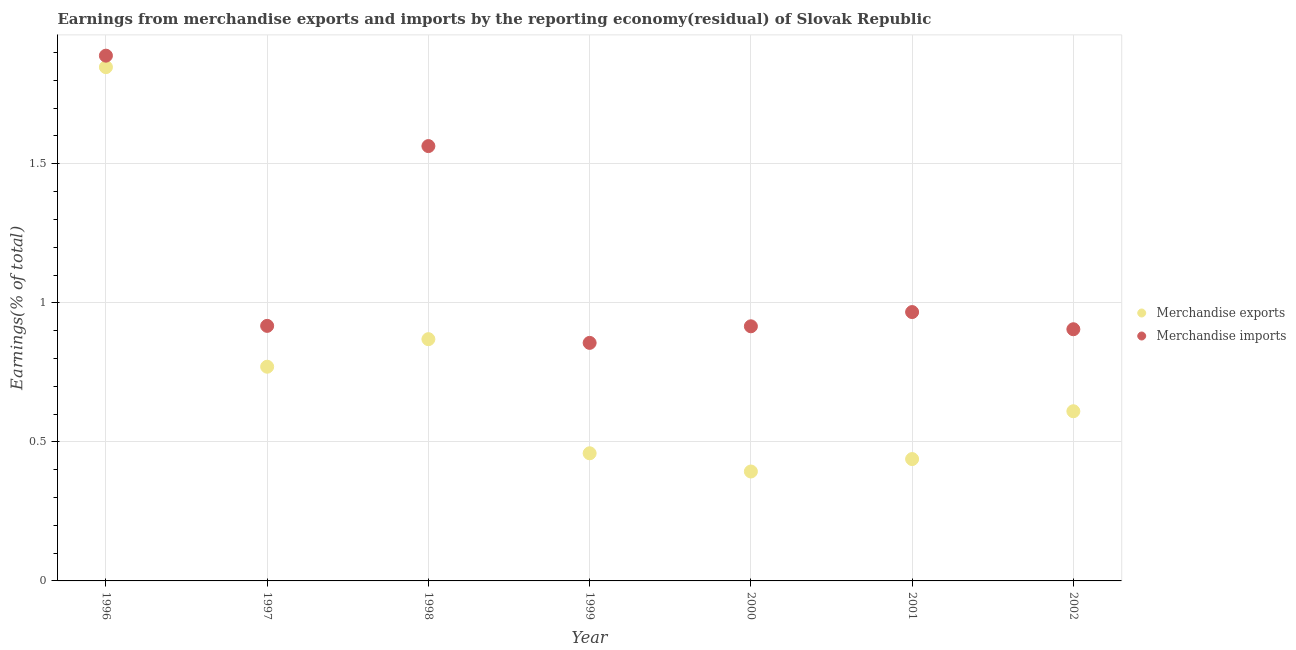How many different coloured dotlines are there?
Provide a succinct answer. 2. Is the number of dotlines equal to the number of legend labels?
Make the answer very short. Yes. What is the earnings from merchandise imports in 1996?
Ensure brevity in your answer.  1.89. Across all years, what is the maximum earnings from merchandise imports?
Ensure brevity in your answer.  1.89. Across all years, what is the minimum earnings from merchandise imports?
Ensure brevity in your answer.  0.86. In which year was the earnings from merchandise imports minimum?
Provide a succinct answer. 1999. What is the total earnings from merchandise exports in the graph?
Your answer should be very brief. 5.39. What is the difference between the earnings from merchandise imports in 1997 and that in 1999?
Give a very brief answer. 0.06. What is the difference between the earnings from merchandise imports in 1997 and the earnings from merchandise exports in 1998?
Provide a short and direct response. 0.05. What is the average earnings from merchandise imports per year?
Provide a succinct answer. 1.14. In the year 2001, what is the difference between the earnings from merchandise exports and earnings from merchandise imports?
Offer a very short reply. -0.53. What is the ratio of the earnings from merchandise exports in 1996 to that in 2001?
Keep it short and to the point. 4.22. Is the earnings from merchandise imports in 1998 less than that in 1999?
Your answer should be very brief. No. What is the difference between the highest and the second highest earnings from merchandise imports?
Your answer should be compact. 0.33. What is the difference between the highest and the lowest earnings from merchandise imports?
Make the answer very short. 1.03. In how many years, is the earnings from merchandise imports greater than the average earnings from merchandise imports taken over all years?
Provide a short and direct response. 2. Does the earnings from merchandise imports monotonically increase over the years?
Offer a very short reply. No. Is the earnings from merchandise imports strictly greater than the earnings from merchandise exports over the years?
Offer a very short reply. Yes. Is the earnings from merchandise imports strictly less than the earnings from merchandise exports over the years?
Provide a short and direct response. No. How many dotlines are there?
Your response must be concise. 2. How many years are there in the graph?
Make the answer very short. 7. Are the values on the major ticks of Y-axis written in scientific E-notation?
Keep it short and to the point. No. Does the graph contain any zero values?
Provide a short and direct response. No. How many legend labels are there?
Keep it short and to the point. 2. What is the title of the graph?
Keep it short and to the point. Earnings from merchandise exports and imports by the reporting economy(residual) of Slovak Republic. What is the label or title of the X-axis?
Your response must be concise. Year. What is the label or title of the Y-axis?
Your answer should be very brief. Earnings(% of total). What is the Earnings(% of total) in Merchandise exports in 1996?
Your answer should be compact. 1.85. What is the Earnings(% of total) of Merchandise imports in 1996?
Your answer should be compact. 1.89. What is the Earnings(% of total) of Merchandise exports in 1997?
Your answer should be compact. 0.77. What is the Earnings(% of total) in Merchandise imports in 1997?
Ensure brevity in your answer.  0.92. What is the Earnings(% of total) of Merchandise exports in 1998?
Make the answer very short. 0.87. What is the Earnings(% of total) in Merchandise imports in 1998?
Your answer should be very brief. 1.56. What is the Earnings(% of total) in Merchandise exports in 1999?
Your response must be concise. 0.46. What is the Earnings(% of total) in Merchandise imports in 1999?
Provide a short and direct response. 0.86. What is the Earnings(% of total) in Merchandise exports in 2000?
Your answer should be very brief. 0.39. What is the Earnings(% of total) of Merchandise imports in 2000?
Offer a terse response. 0.92. What is the Earnings(% of total) in Merchandise exports in 2001?
Offer a terse response. 0.44. What is the Earnings(% of total) of Merchandise imports in 2001?
Offer a terse response. 0.97. What is the Earnings(% of total) of Merchandise exports in 2002?
Ensure brevity in your answer.  0.61. What is the Earnings(% of total) in Merchandise imports in 2002?
Offer a very short reply. 0.9. Across all years, what is the maximum Earnings(% of total) of Merchandise exports?
Offer a very short reply. 1.85. Across all years, what is the maximum Earnings(% of total) of Merchandise imports?
Make the answer very short. 1.89. Across all years, what is the minimum Earnings(% of total) in Merchandise exports?
Ensure brevity in your answer.  0.39. Across all years, what is the minimum Earnings(% of total) in Merchandise imports?
Give a very brief answer. 0.86. What is the total Earnings(% of total) in Merchandise exports in the graph?
Make the answer very short. 5.39. What is the total Earnings(% of total) of Merchandise imports in the graph?
Give a very brief answer. 8.01. What is the difference between the Earnings(% of total) in Merchandise exports in 1996 and that in 1997?
Your answer should be compact. 1.08. What is the difference between the Earnings(% of total) of Merchandise imports in 1996 and that in 1997?
Your answer should be very brief. 0.97. What is the difference between the Earnings(% of total) in Merchandise exports in 1996 and that in 1998?
Your answer should be compact. 0.98. What is the difference between the Earnings(% of total) in Merchandise imports in 1996 and that in 1998?
Offer a terse response. 0.33. What is the difference between the Earnings(% of total) of Merchandise exports in 1996 and that in 1999?
Ensure brevity in your answer.  1.39. What is the difference between the Earnings(% of total) of Merchandise imports in 1996 and that in 1999?
Your answer should be very brief. 1.03. What is the difference between the Earnings(% of total) of Merchandise exports in 1996 and that in 2000?
Provide a short and direct response. 1.45. What is the difference between the Earnings(% of total) in Merchandise imports in 1996 and that in 2000?
Provide a succinct answer. 0.97. What is the difference between the Earnings(% of total) in Merchandise exports in 1996 and that in 2001?
Make the answer very short. 1.41. What is the difference between the Earnings(% of total) in Merchandise imports in 1996 and that in 2001?
Keep it short and to the point. 0.92. What is the difference between the Earnings(% of total) in Merchandise exports in 1996 and that in 2002?
Provide a succinct answer. 1.24. What is the difference between the Earnings(% of total) in Merchandise imports in 1996 and that in 2002?
Give a very brief answer. 0.98. What is the difference between the Earnings(% of total) of Merchandise exports in 1997 and that in 1998?
Your answer should be compact. -0.1. What is the difference between the Earnings(% of total) in Merchandise imports in 1997 and that in 1998?
Offer a terse response. -0.65. What is the difference between the Earnings(% of total) in Merchandise exports in 1997 and that in 1999?
Ensure brevity in your answer.  0.31. What is the difference between the Earnings(% of total) of Merchandise imports in 1997 and that in 1999?
Your answer should be compact. 0.06. What is the difference between the Earnings(% of total) in Merchandise exports in 1997 and that in 2000?
Give a very brief answer. 0.38. What is the difference between the Earnings(% of total) of Merchandise imports in 1997 and that in 2000?
Offer a terse response. 0. What is the difference between the Earnings(% of total) in Merchandise exports in 1997 and that in 2001?
Provide a succinct answer. 0.33. What is the difference between the Earnings(% of total) in Merchandise imports in 1997 and that in 2001?
Offer a very short reply. -0.05. What is the difference between the Earnings(% of total) in Merchandise exports in 1997 and that in 2002?
Offer a very short reply. 0.16. What is the difference between the Earnings(% of total) in Merchandise imports in 1997 and that in 2002?
Make the answer very short. 0.01. What is the difference between the Earnings(% of total) of Merchandise exports in 1998 and that in 1999?
Ensure brevity in your answer.  0.41. What is the difference between the Earnings(% of total) of Merchandise imports in 1998 and that in 1999?
Your response must be concise. 0.71. What is the difference between the Earnings(% of total) in Merchandise exports in 1998 and that in 2000?
Your response must be concise. 0.48. What is the difference between the Earnings(% of total) in Merchandise imports in 1998 and that in 2000?
Your response must be concise. 0.65. What is the difference between the Earnings(% of total) of Merchandise exports in 1998 and that in 2001?
Provide a short and direct response. 0.43. What is the difference between the Earnings(% of total) in Merchandise imports in 1998 and that in 2001?
Offer a terse response. 0.6. What is the difference between the Earnings(% of total) in Merchandise exports in 1998 and that in 2002?
Make the answer very short. 0.26. What is the difference between the Earnings(% of total) of Merchandise imports in 1998 and that in 2002?
Your response must be concise. 0.66. What is the difference between the Earnings(% of total) of Merchandise exports in 1999 and that in 2000?
Your response must be concise. 0.07. What is the difference between the Earnings(% of total) in Merchandise imports in 1999 and that in 2000?
Keep it short and to the point. -0.06. What is the difference between the Earnings(% of total) in Merchandise exports in 1999 and that in 2001?
Provide a succinct answer. 0.02. What is the difference between the Earnings(% of total) in Merchandise imports in 1999 and that in 2001?
Ensure brevity in your answer.  -0.11. What is the difference between the Earnings(% of total) in Merchandise exports in 1999 and that in 2002?
Offer a very short reply. -0.15. What is the difference between the Earnings(% of total) of Merchandise imports in 1999 and that in 2002?
Offer a very short reply. -0.05. What is the difference between the Earnings(% of total) in Merchandise exports in 2000 and that in 2001?
Ensure brevity in your answer.  -0.04. What is the difference between the Earnings(% of total) in Merchandise imports in 2000 and that in 2001?
Give a very brief answer. -0.05. What is the difference between the Earnings(% of total) of Merchandise exports in 2000 and that in 2002?
Provide a succinct answer. -0.22. What is the difference between the Earnings(% of total) of Merchandise imports in 2000 and that in 2002?
Your answer should be very brief. 0.01. What is the difference between the Earnings(% of total) in Merchandise exports in 2001 and that in 2002?
Offer a very short reply. -0.17. What is the difference between the Earnings(% of total) of Merchandise imports in 2001 and that in 2002?
Offer a terse response. 0.06. What is the difference between the Earnings(% of total) of Merchandise exports in 1996 and the Earnings(% of total) of Merchandise imports in 1997?
Give a very brief answer. 0.93. What is the difference between the Earnings(% of total) in Merchandise exports in 1996 and the Earnings(% of total) in Merchandise imports in 1998?
Your answer should be compact. 0.28. What is the difference between the Earnings(% of total) of Merchandise exports in 1996 and the Earnings(% of total) of Merchandise imports in 1999?
Your response must be concise. 0.99. What is the difference between the Earnings(% of total) of Merchandise exports in 1996 and the Earnings(% of total) of Merchandise imports in 2000?
Offer a very short reply. 0.93. What is the difference between the Earnings(% of total) in Merchandise exports in 1996 and the Earnings(% of total) in Merchandise imports in 2001?
Give a very brief answer. 0.88. What is the difference between the Earnings(% of total) of Merchandise exports in 1996 and the Earnings(% of total) of Merchandise imports in 2002?
Keep it short and to the point. 0.94. What is the difference between the Earnings(% of total) in Merchandise exports in 1997 and the Earnings(% of total) in Merchandise imports in 1998?
Your response must be concise. -0.79. What is the difference between the Earnings(% of total) in Merchandise exports in 1997 and the Earnings(% of total) in Merchandise imports in 1999?
Your answer should be compact. -0.09. What is the difference between the Earnings(% of total) of Merchandise exports in 1997 and the Earnings(% of total) of Merchandise imports in 2000?
Provide a short and direct response. -0.15. What is the difference between the Earnings(% of total) in Merchandise exports in 1997 and the Earnings(% of total) in Merchandise imports in 2001?
Provide a short and direct response. -0.2. What is the difference between the Earnings(% of total) of Merchandise exports in 1997 and the Earnings(% of total) of Merchandise imports in 2002?
Make the answer very short. -0.13. What is the difference between the Earnings(% of total) of Merchandise exports in 1998 and the Earnings(% of total) of Merchandise imports in 1999?
Give a very brief answer. 0.01. What is the difference between the Earnings(% of total) of Merchandise exports in 1998 and the Earnings(% of total) of Merchandise imports in 2000?
Ensure brevity in your answer.  -0.05. What is the difference between the Earnings(% of total) of Merchandise exports in 1998 and the Earnings(% of total) of Merchandise imports in 2001?
Give a very brief answer. -0.1. What is the difference between the Earnings(% of total) in Merchandise exports in 1998 and the Earnings(% of total) in Merchandise imports in 2002?
Offer a very short reply. -0.04. What is the difference between the Earnings(% of total) in Merchandise exports in 1999 and the Earnings(% of total) in Merchandise imports in 2000?
Provide a succinct answer. -0.46. What is the difference between the Earnings(% of total) of Merchandise exports in 1999 and the Earnings(% of total) of Merchandise imports in 2001?
Keep it short and to the point. -0.51. What is the difference between the Earnings(% of total) of Merchandise exports in 1999 and the Earnings(% of total) of Merchandise imports in 2002?
Make the answer very short. -0.45. What is the difference between the Earnings(% of total) in Merchandise exports in 2000 and the Earnings(% of total) in Merchandise imports in 2001?
Your answer should be compact. -0.57. What is the difference between the Earnings(% of total) in Merchandise exports in 2000 and the Earnings(% of total) in Merchandise imports in 2002?
Your answer should be very brief. -0.51. What is the difference between the Earnings(% of total) of Merchandise exports in 2001 and the Earnings(% of total) of Merchandise imports in 2002?
Offer a terse response. -0.47. What is the average Earnings(% of total) in Merchandise exports per year?
Your response must be concise. 0.77. What is the average Earnings(% of total) in Merchandise imports per year?
Make the answer very short. 1.14. In the year 1996, what is the difference between the Earnings(% of total) in Merchandise exports and Earnings(% of total) in Merchandise imports?
Keep it short and to the point. -0.04. In the year 1997, what is the difference between the Earnings(% of total) in Merchandise exports and Earnings(% of total) in Merchandise imports?
Your answer should be compact. -0.15. In the year 1998, what is the difference between the Earnings(% of total) in Merchandise exports and Earnings(% of total) in Merchandise imports?
Your answer should be very brief. -0.69. In the year 1999, what is the difference between the Earnings(% of total) of Merchandise exports and Earnings(% of total) of Merchandise imports?
Your answer should be compact. -0.4. In the year 2000, what is the difference between the Earnings(% of total) in Merchandise exports and Earnings(% of total) in Merchandise imports?
Provide a short and direct response. -0.52. In the year 2001, what is the difference between the Earnings(% of total) of Merchandise exports and Earnings(% of total) of Merchandise imports?
Keep it short and to the point. -0.53. In the year 2002, what is the difference between the Earnings(% of total) of Merchandise exports and Earnings(% of total) of Merchandise imports?
Offer a very short reply. -0.29. What is the ratio of the Earnings(% of total) of Merchandise exports in 1996 to that in 1997?
Make the answer very short. 2.4. What is the ratio of the Earnings(% of total) of Merchandise imports in 1996 to that in 1997?
Provide a succinct answer. 2.06. What is the ratio of the Earnings(% of total) of Merchandise exports in 1996 to that in 1998?
Offer a terse response. 2.13. What is the ratio of the Earnings(% of total) in Merchandise imports in 1996 to that in 1998?
Your response must be concise. 1.21. What is the ratio of the Earnings(% of total) in Merchandise exports in 1996 to that in 1999?
Your answer should be very brief. 4.03. What is the ratio of the Earnings(% of total) in Merchandise imports in 1996 to that in 1999?
Provide a succinct answer. 2.21. What is the ratio of the Earnings(% of total) of Merchandise exports in 1996 to that in 2000?
Keep it short and to the point. 4.7. What is the ratio of the Earnings(% of total) in Merchandise imports in 1996 to that in 2000?
Ensure brevity in your answer.  2.06. What is the ratio of the Earnings(% of total) in Merchandise exports in 1996 to that in 2001?
Your response must be concise. 4.22. What is the ratio of the Earnings(% of total) in Merchandise imports in 1996 to that in 2001?
Offer a terse response. 1.95. What is the ratio of the Earnings(% of total) of Merchandise exports in 1996 to that in 2002?
Offer a very short reply. 3.03. What is the ratio of the Earnings(% of total) of Merchandise imports in 1996 to that in 2002?
Provide a succinct answer. 2.09. What is the ratio of the Earnings(% of total) in Merchandise exports in 1997 to that in 1998?
Offer a terse response. 0.89. What is the ratio of the Earnings(% of total) of Merchandise imports in 1997 to that in 1998?
Provide a succinct answer. 0.59. What is the ratio of the Earnings(% of total) of Merchandise exports in 1997 to that in 1999?
Offer a terse response. 1.68. What is the ratio of the Earnings(% of total) of Merchandise imports in 1997 to that in 1999?
Provide a short and direct response. 1.07. What is the ratio of the Earnings(% of total) of Merchandise exports in 1997 to that in 2000?
Ensure brevity in your answer.  1.96. What is the ratio of the Earnings(% of total) of Merchandise exports in 1997 to that in 2001?
Ensure brevity in your answer.  1.76. What is the ratio of the Earnings(% of total) in Merchandise imports in 1997 to that in 2001?
Keep it short and to the point. 0.95. What is the ratio of the Earnings(% of total) of Merchandise exports in 1997 to that in 2002?
Ensure brevity in your answer.  1.26. What is the ratio of the Earnings(% of total) of Merchandise imports in 1997 to that in 2002?
Offer a very short reply. 1.01. What is the ratio of the Earnings(% of total) of Merchandise exports in 1998 to that in 1999?
Your answer should be compact. 1.89. What is the ratio of the Earnings(% of total) of Merchandise imports in 1998 to that in 1999?
Your answer should be very brief. 1.83. What is the ratio of the Earnings(% of total) of Merchandise exports in 1998 to that in 2000?
Provide a succinct answer. 2.21. What is the ratio of the Earnings(% of total) in Merchandise imports in 1998 to that in 2000?
Your answer should be very brief. 1.71. What is the ratio of the Earnings(% of total) of Merchandise exports in 1998 to that in 2001?
Your answer should be very brief. 1.98. What is the ratio of the Earnings(% of total) in Merchandise imports in 1998 to that in 2001?
Make the answer very short. 1.62. What is the ratio of the Earnings(% of total) in Merchandise exports in 1998 to that in 2002?
Your answer should be very brief. 1.42. What is the ratio of the Earnings(% of total) in Merchandise imports in 1998 to that in 2002?
Ensure brevity in your answer.  1.73. What is the ratio of the Earnings(% of total) in Merchandise exports in 1999 to that in 2000?
Offer a very short reply. 1.17. What is the ratio of the Earnings(% of total) in Merchandise imports in 1999 to that in 2000?
Your response must be concise. 0.93. What is the ratio of the Earnings(% of total) of Merchandise exports in 1999 to that in 2001?
Your answer should be very brief. 1.05. What is the ratio of the Earnings(% of total) of Merchandise imports in 1999 to that in 2001?
Your response must be concise. 0.89. What is the ratio of the Earnings(% of total) in Merchandise exports in 1999 to that in 2002?
Keep it short and to the point. 0.75. What is the ratio of the Earnings(% of total) of Merchandise imports in 1999 to that in 2002?
Provide a short and direct response. 0.95. What is the ratio of the Earnings(% of total) of Merchandise exports in 2000 to that in 2001?
Your answer should be compact. 0.9. What is the ratio of the Earnings(% of total) in Merchandise imports in 2000 to that in 2001?
Provide a succinct answer. 0.95. What is the ratio of the Earnings(% of total) of Merchandise exports in 2000 to that in 2002?
Provide a succinct answer. 0.64. What is the ratio of the Earnings(% of total) in Merchandise imports in 2000 to that in 2002?
Make the answer very short. 1.01. What is the ratio of the Earnings(% of total) in Merchandise exports in 2001 to that in 2002?
Offer a terse response. 0.72. What is the ratio of the Earnings(% of total) in Merchandise imports in 2001 to that in 2002?
Your answer should be very brief. 1.07. What is the difference between the highest and the second highest Earnings(% of total) in Merchandise exports?
Make the answer very short. 0.98. What is the difference between the highest and the second highest Earnings(% of total) of Merchandise imports?
Provide a succinct answer. 0.33. What is the difference between the highest and the lowest Earnings(% of total) in Merchandise exports?
Your answer should be compact. 1.45. What is the difference between the highest and the lowest Earnings(% of total) of Merchandise imports?
Ensure brevity in your answer.  1.03. 